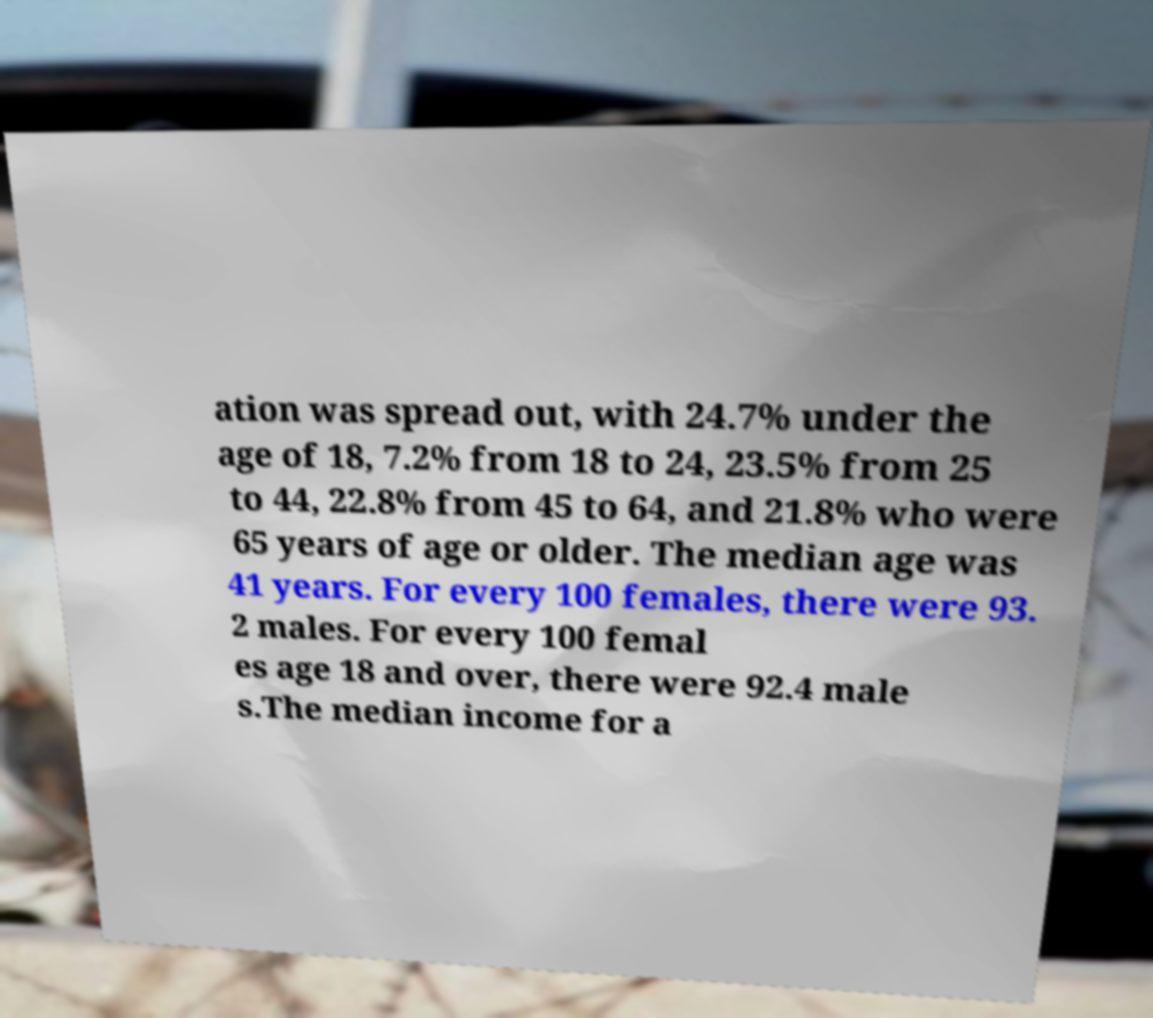I need the written content from this picture converted into text. Can you do that? ation was spread out, with 24.7% under the age of 18, 7.2% from 18 to 24, 23.5% from 25 to 44, 22.8% from 45 to 64, and 21.8% who were 65 years of age or older. The median age was 41 years. For every 100 females, there were 93. 2 males. For every 100 femal es age 18 and over, there were 92.4 male s.The median income for a 